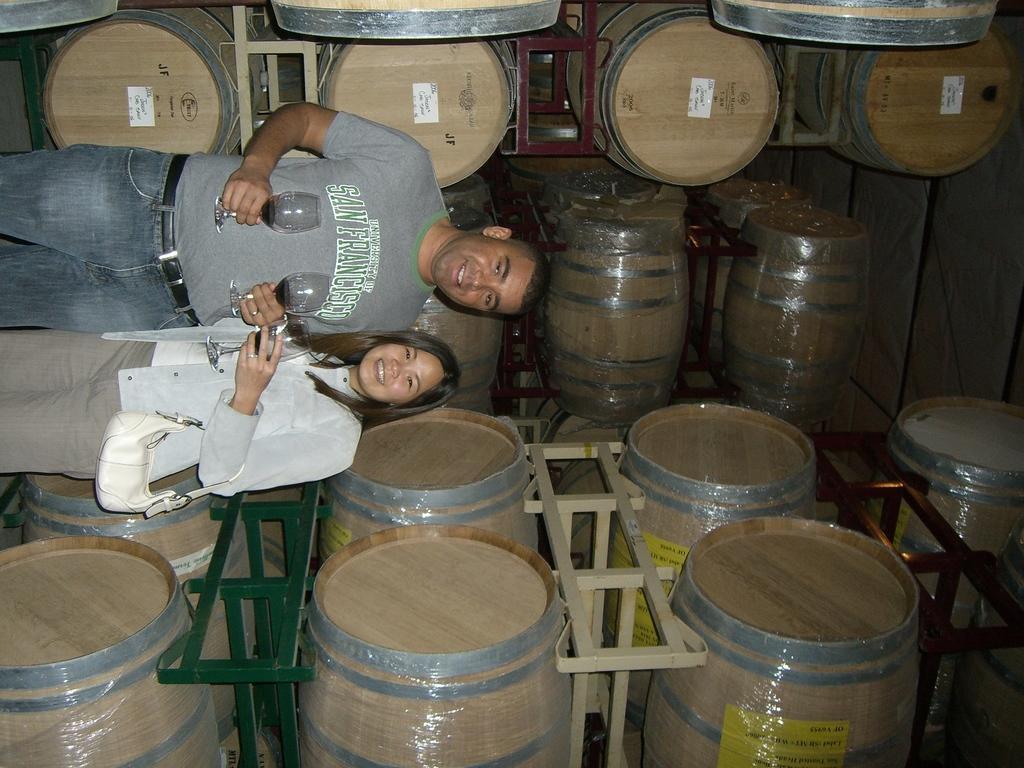Please provide a concise description of this image. In the foreground of this image, there is a couple standing holding glasses and the woman is holding a bag. In the background, there are barrels on the stand and on the right, there is the inside roof. 